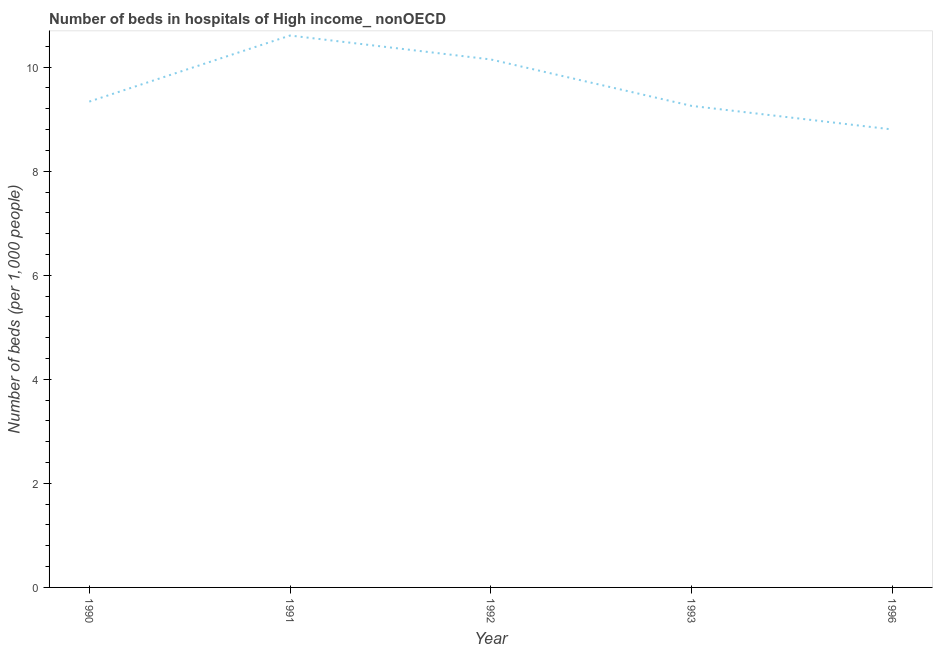What is the number of hospital beds in 1996?
Keep it short and to the point. 8.8. Across all years, what is the maximum number of hospital beds?
Your answer should be very brief. 10.61. Across all years, what is the minimum number of hospital beds?
Ensure brevity in your answer.  8.8. What is the sum of the number of hospital beds?
Your answer should be compact. 48.15. What is the difference between the number of hospital beds in 1993 and 1996?
Your response must be concise. 0.45. What is the average number of hospital beds per year?
Keep it short and to the point. 9.63. What is the median number of hospital beds?
Your answer should be very brief. 9.34. In how many years, is the number of hospital beds greater than 7.6 %?
Your answer should be compact. 5. What is the ratio of the number of hospital beds in 1993 to that in 1996?
Your answer should be very brief. 1.05. Is the number of hospital beds in 1991 less than that in 1996?
Make the answer very short. No. What is the difference between the highest and the second highest number of hospital beds?
Keep it short and to the point. 0.46. Is the sum of the number of hospital beds in 1990 and 1996 greater than the maximum number of hospital beds across all years?
Your answer should be very brief. Yes. What is the difference between the highest and the lowest number of hospital beds?
Give a very brief answer. 1.81. In how many years, is the number of hospital beds greater than the average number of hospital beds taken over all years?
Ensure brevity in your answer.  2. How many lines are there?
Give a very brief answer. 1. What is the difference between two consecutive major ticks on the Y-axis?
Your answer should be very brief. 2. Does the graph contain grids?
Make the answer very short. No. What is the title of the graph?
Make the answer very short. Number of beds in hospitals of High income_ nonOECD. What is the label or title of the Y-axis?
Offer a very short reply. Number of beds (per 1,0 people). What is the Number of beds (per 1,000 people) in 1990?
Ensure brevity in your answer.  9.34. What is the Number of beds (per 1,000 people) in 1991?
Give a very brief answer. 10.61. What is the Number of beds (per 1,000 people) of 1992?
Your answer should be compact. 10.15. What is the Number of beds (per 1,000 people) of 1993?
Provide a short and direct response. 9.26. What is the Number of beds (per 1,000 people) of 1996?
Provide a short and direct response. 8.8. What is the difference between the Number of beds (per 1,000 people) in 1990 and 1991?
Your response must be concise. -1.27. What is the difference between the Number of beds (per 1,000 people) in 1990 and 1992?
Keep it short and to the point. -0.81. What is the difference between the Number of beds (per 1,000 people) in 1990 and 1993?
Offer a terse response. 0.08. What is the difference between the Number of beds (per 1,000 people) in 1990 and 1996?
Provide a succinct answer. 0.54. What is the difference between the Number of beds (per 1,000 people) in 1991 and 1992?
Your answer should be compact. 0.46. What is the difference between the Number of beds (per 1,000 people) in 1991 and 1993?
Make the answer very short. 1.35. What is the difference between the Number of beds (per 1,000 people) in 1991 and 1996?
Your response must be concise. 1.81. What is the difference between the Number of beds (per 1,000 people) in 1992 and 1993?
Make the answer very short. 0.89. What is the difference between the Number of beds (per 1,000 people) in 1992 and 1996?
Keep it short and to the point. 1.35. What is the difference between the Number of beds (per 1,000 people) in 1993 and 1996?
Your answer should be very brief. 0.45. What is the ratio of the Number of beds (per 1,000 people) in 1990 to that in 1992?
Offer a terse response. 0.92. What is the ratio of the Number of beds (per 1,000 people) in 1990 to that in 1993?
Make the answer very short. 1.01. What is the ratio of the Number of beds (per 1,000 people) in 1990 to that in 1996?
Give a very brief answer. 1.06. What is the ratio of the Number of beds (per 1,000 people) in 1991 to that in 1992?
Offer a very short reply. 1.04. What is the ratio of the Number of beds (per 1,000 people) in 1991 to that in 1993?
Give a very brief answer. 1.15. What is the ratio of the Number of beds (per 1,000 people) in 1991 to that in 1996?
Keep it short and to the point. 1.21. What is the ratio of the Number of beds (per 1,000 people) in 1992 to that in 1993?
Your answer should be compact. 1.1. What is the ratio of the Number of beds (per 1,000 people) in 1992 to that in 1996?
Ensure brevity in your answer.  1.15. What is the ratio of the Number of beds (per 1,000 people) in 1993 to that in 1996?
Give a very brief answer. 1.05. 